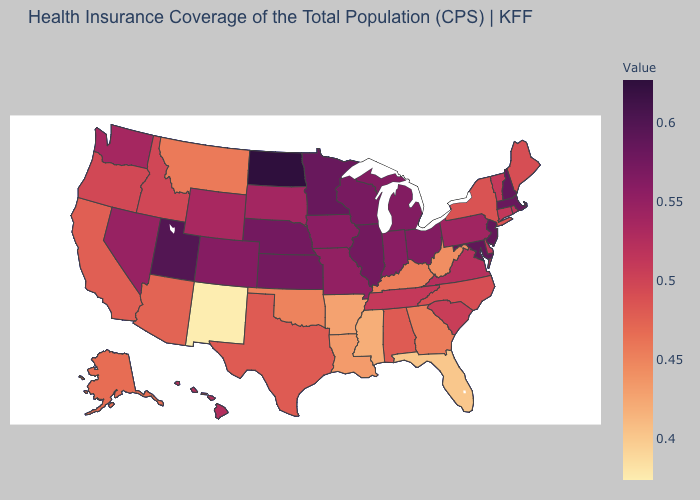Which states have the lowest value in the Northeast?
Answer briefly. New York. Which states have the highest value in the USA?
Answer briefly. North Dakota. Does New Mexico have the lowest value in the West?
Be succinct. Yes. Among the states that border Nebraska , does Missouri have the highest value?
Write a very short answer. No. 